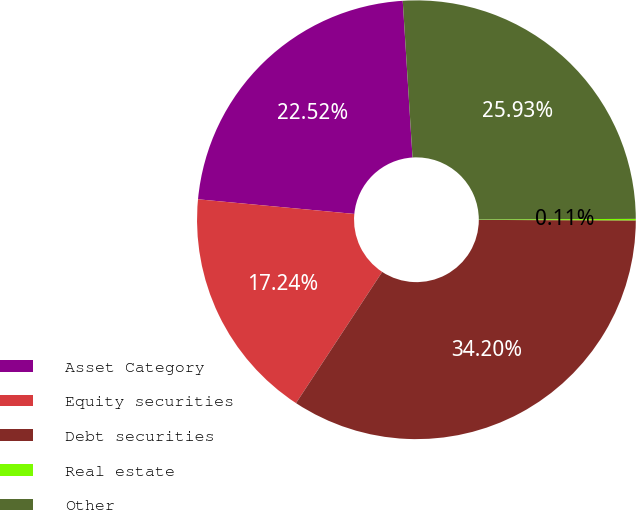Convert chart. <chart><loc_0><loc_0><loc_500><loc_500><pie_chart><fcel>Asset Category<fcel>Equity securities<fcel>Debt securities<fcel>Real estate<fcel>Other<nl><fcel>22.52%<fcel>17.24%<fcel>34.2%<fcel>0.11%<fcel>25.93%<nl></chart> 